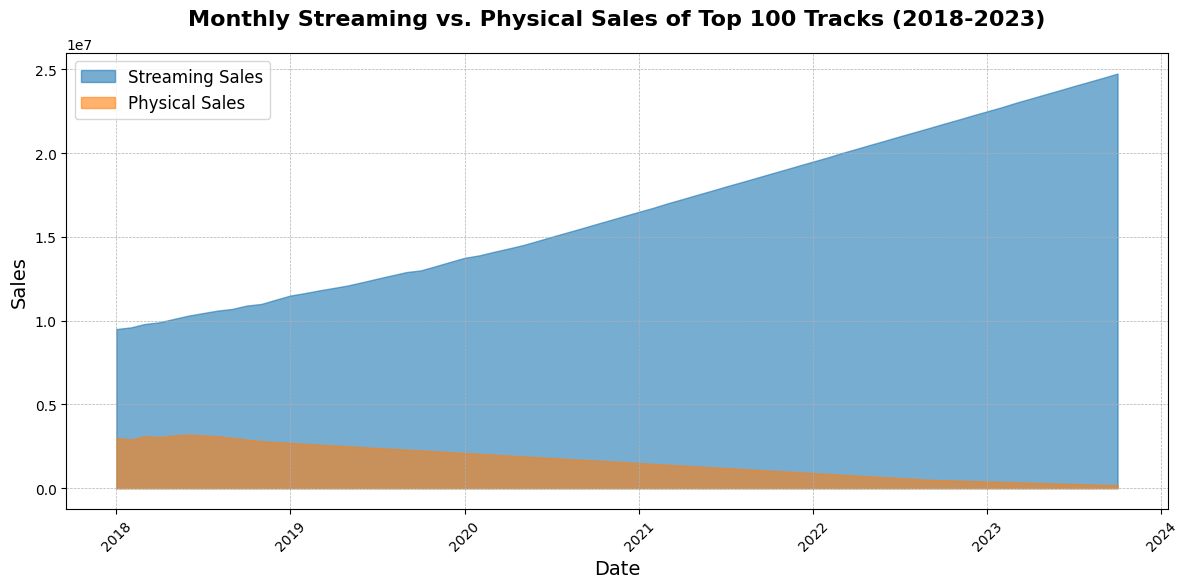What is the overall trend in Streaming Sales over the past 5 years? The area representing Streaming Sales steadily increases from 2018 to 2023, showing a clear upward trend throughout the entire period.
Answer: Upward trend Compare the highest and lowest points of Physical Sales in the period from 2018 to 2023. The highest point for Physical Sales occurs at the beginning of 2018 (3,150,000 units in May 2018), while the lowest point occurs at the end of the dataset in October 2023 (180,000 units).
Answer: Highest: 3,150,000; Lowest: 180,000 By how much did Streaming Sales increase from January 2018 to October 2023? The Streaming Sales were 9,500,000 units in January 2018 and increased to 24,750,000 units by October 2023. So, the increase is 24,750,000 - 9,500,000 = 15,250,000 units.
Answer: 15,250,000 units What month and year did Streaming Sales surpass 20,000,000 units, and how did Physical Sales compare at that time? Streaming Sales surpassed 20,000,000 units in March 2022, while Physical Sales were at 800,000 units.
Answer: March 2022, 800,000 units Which year saw the steepest decline in Physical Sales? The most significant decline in Physical Sales can be observed in the year 2020, as the decline from January 2020 (2,100,000 units) to December 2020 (1,550,000 units) shows the largest drop within a single year.
Answer: 2020 In what month and year did Streaming Sales first exceed Physical Sales, and what were the respective sales figures? Streaming Sales first exceeded Physical Sales in August 2018. Streaming Sales were 10,600,000 units, while Physical Sales were 3,100,000 units.
Answer: August 2018, 10,600,000 units vs. 3,100,000 units Calculate the average monthly Physical Sales in 2019. The Physical Sales for 2019 are: 2,700,000, 2,650,000, 2,600,000, 2,550,000, 2,500,000, 2,450,000, 2,400,000, 2,350,000, 2,300,000, 2,250,000, 2,200,000, and 2,150,000 units. Summing these gives 29,550,000 units. Dividing by 12 months gives an average of 29,550,000 / 12 = 2,462,500 units.
Answer: 2,462,500 units Compare the changes in Streaming Sales and Physical Sales between January 2020 and January 2021. In January 2020, Streaming Sales were 13,750,000 units and increased to 16,500,000 units by January 2021, a rise of 2,750,000 units. For Physical Sales, January 2020 saw 2,100,000 units, which decreased to 1,500,000 units by January 2021, a decline of 600,000 units.
Answer: Streaming Sales increase: 2,750,000; Physical Sales decrease: 600,000 